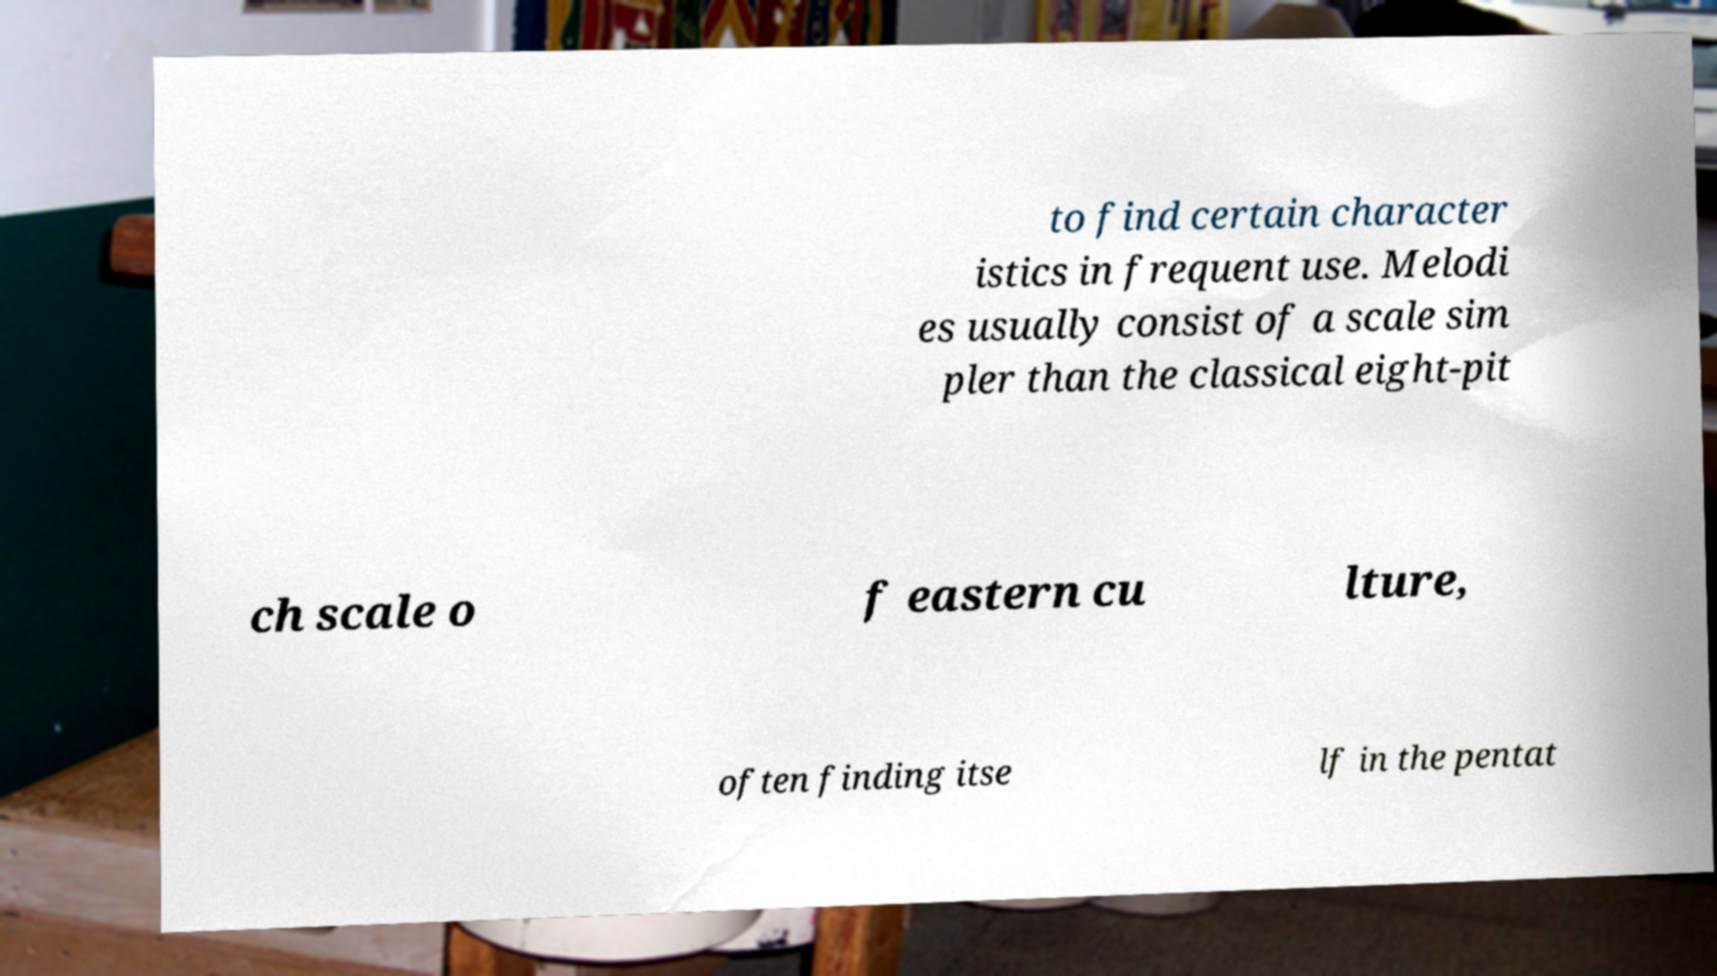What messages or text are displayed in this image? I need them in a readable, typed format. to find certain character istics in frequent use. Melodi es usually consist of a scale sim pler than the classical eight-pit ch scale o f eastern cu lture, often finding itse lf in the pentat 